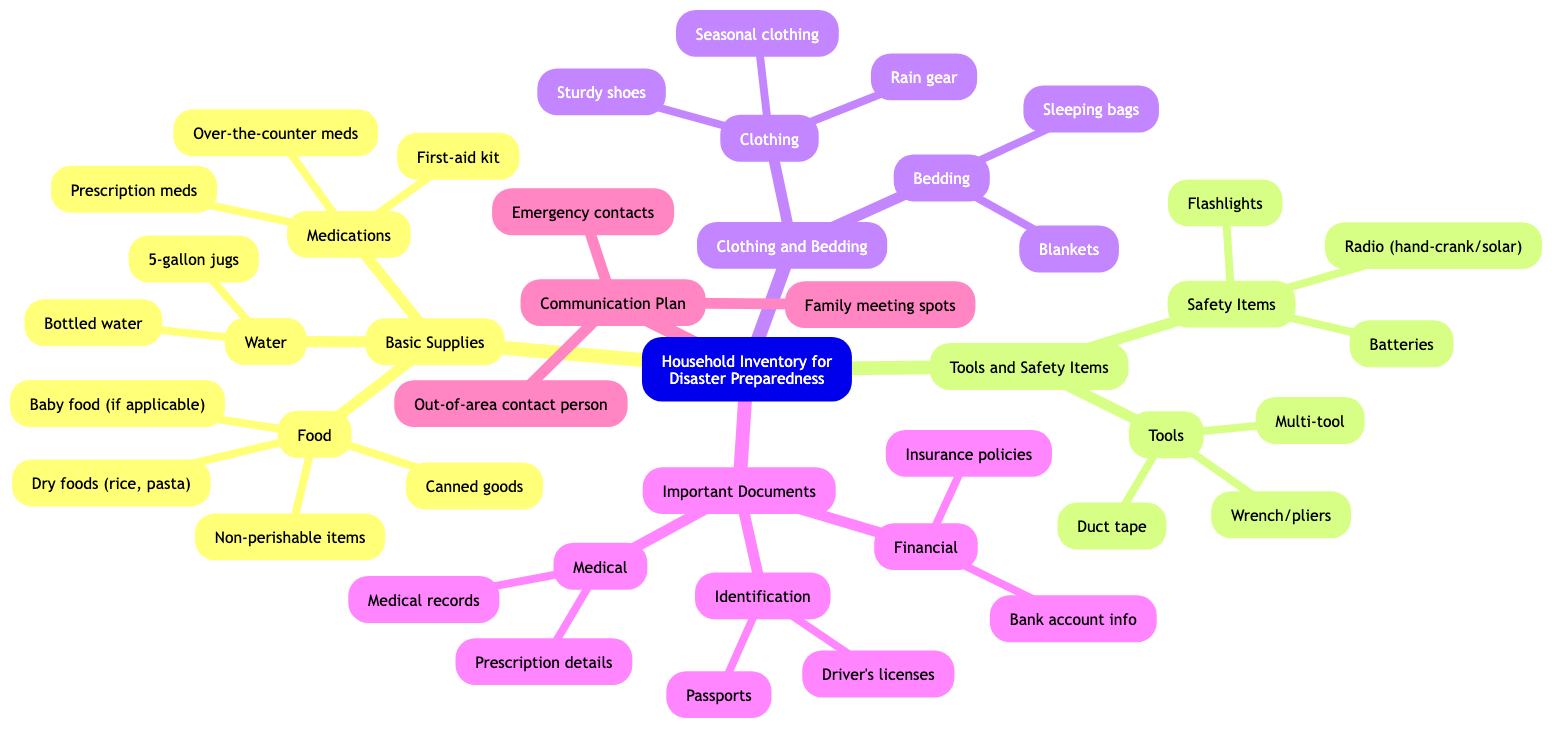What is the main subject of the diagram? The diagram outlines various categories of items that households should have prepared in case of disasters. The root node clearly states "Household Inventory for Disaster Preparedness," indicating that the main focus is on preparedness items for emergencies.
Answer: Household Inventory for Disaster Preparedness How many categories are there under the Basic Supplies node? By examining the structure beneath the "Basic Supplies" node, we can count the three child nodes it has: "Food," "Water," and "Medications." Therefore, the total number of categories under "Basic Supplies" is three.
Answer: 3 What type of items are included in the Tools category? Within the "Tools" node, three specific items are listed: "Multi-tool," "Duct tape," and "Wrench/pliers." This indicates that "Tools" refers to functional items useful during emergencies for repairs or securing items.
Answer: Multi-tool, Duct tape, Wrench/pliers Which node contains information about family communication during disasters? The "Communication Plan" node directly addresses the important aspects of family communication in case of emergencies. This suggests that it encapsulates necessary contacts and locations relevant for disaster situations.
Answer: Communication Plan What is the total number of safety items listed? The "Safety Items" node includes three entries: "Flashlights," "Batteries," and "Radio (hand-crank/solar)." By counting these, we see that there are three specific safety items in total listed.
Answer: 3 What two types of important documents are highlighted in the diagram? The "Important Documents" category has three sub-nodes: "Identification," "Financial," and "Medical." Therefore, the answer will encompass two types, and one example can be drawn from any two of these sub-nodes, e.g., "Identification" and "Financial."
Answer: Identification, Financial Which category includes Baby food? Baby food is listed as a child node under the "Food" section within the "Basic Supplies" area. This shows that it's specifically included for households with infants, emphasizing comprehensive preparedness.
Answer: Food What emergency supplies are specified under the Medications node? The "Medications" node includes: "Prescription meds," "Over-the-counter meds," and "First-aid kit." This implies a quick reference for necessary health items needed during a disaster.
Answer: Prescription meds, Over-the-counter meds, First-aid kit Which node discusses seasonal needs for family members? The "Clothing" section under "Clothing and Bedding" handles this aspect, as it directly mentions "Seasonal clothing." This inclusion is essential for ensuring the family is prepared for various weather conditions.
Answer: Clothing 